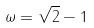Convert formula to latex. <formula><loc_0><loc_0><loc_500><loc_500>\omega = \sqrt { 2 } - 1</formula> 